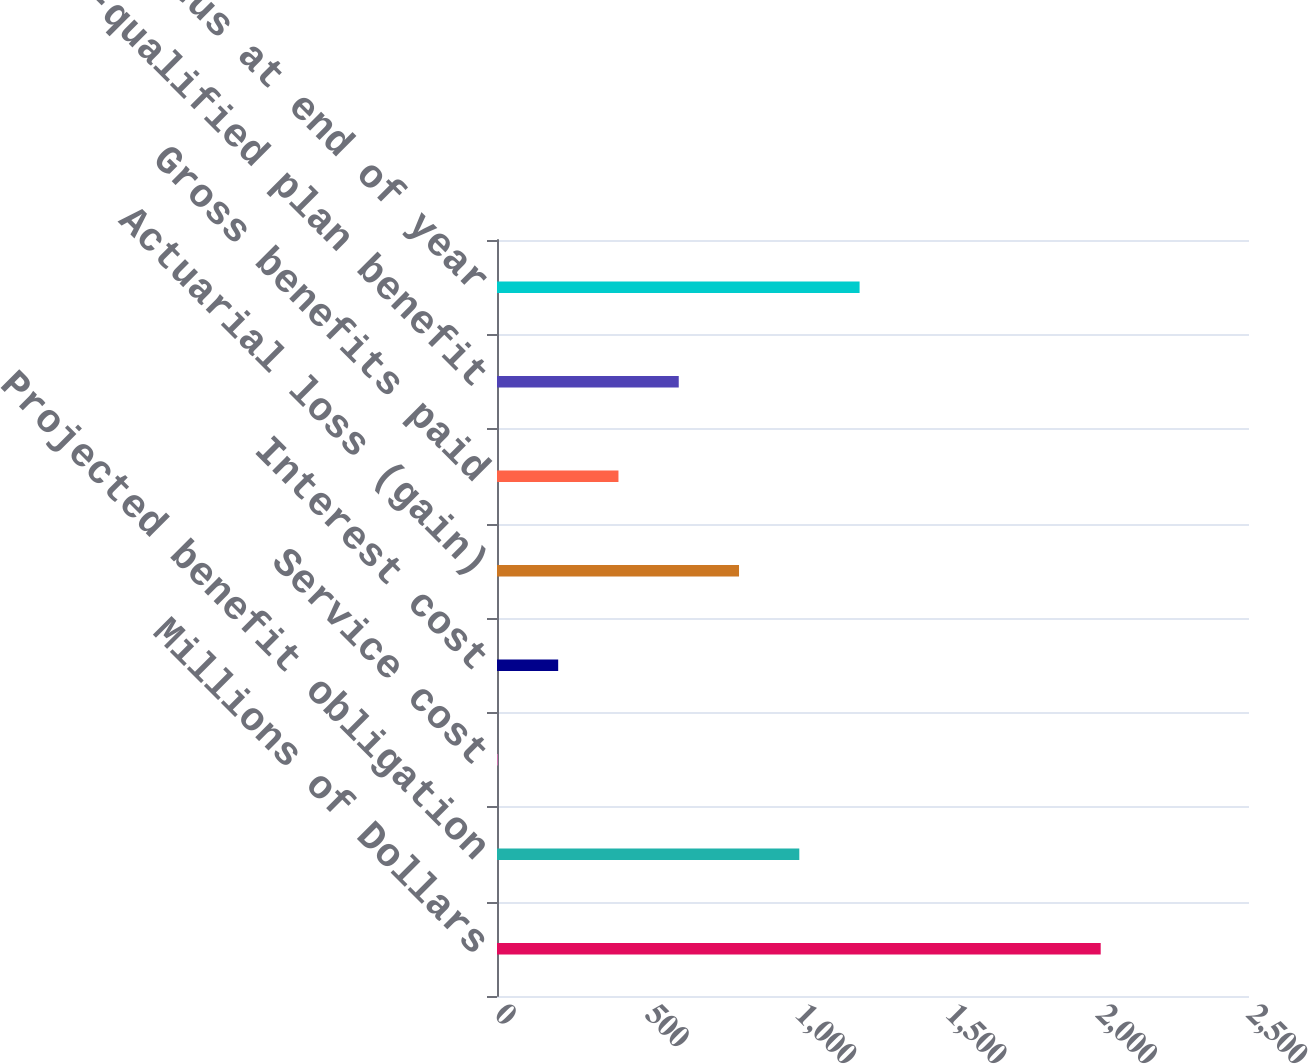Convert chart to OTSL. <chart><loc_0><loc_0><loc_500><loc_500><bar_chart><fcel>Millions of Dollars<fcel>Projected benefit obligation<fcel>Service cost<fcel>Interest cost<fcel>Actuarial loss (gain)<fcel>Gross benefits paid<fcel>Non-qualified plan benefit<fcel>Funded status at end of year<nl><fcel>2007<fcel>1005<fcel>3<fcel>203.4<fcel>804.6<fcel>403.8<fcel>604.2<fcel>1205.4<nl></chart> 